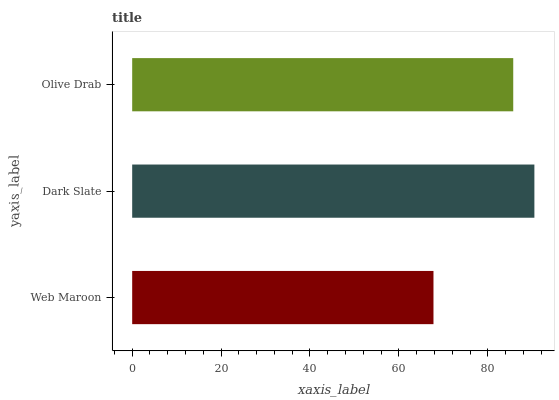Is Web Maroon the minimum?
Answer yes or no. Yes. Is Dark Slate the maximum?
Answer yes or no. Yes. Is Olive Drab the minimum?
Answer yes or no. No. Is Olive Drab the maximum?
Answer yes or no. No. Is Dark Slate greater than Olive Drab?
Answer yes or no. Yes. Is Olive Drab less than Dark Slate?
Answer yes or no. Yes. Is Olive Drab greater than Dark Slate?
Answer yes or no. No. Is Dark Slate less than Olive Drab?
Answer yes or no. No. Is Olive Drab the high median?
Answer yes or no. Yes. Is Olive Drab the low median?
Answer yes or no. Yes. Is Web Maroon the high median?
Answer yes or no. No. Is Web Maroon the low median?
Answer yes or no. No. 